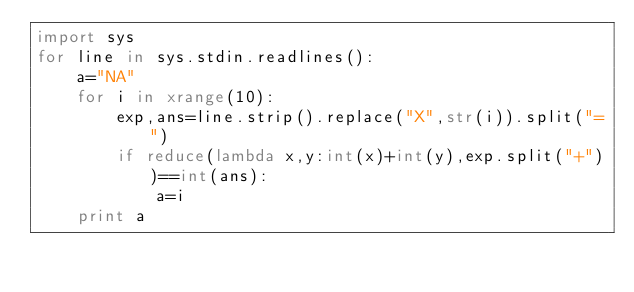Convert code to text. <code><loc_0><loc_0><loc_500><loc_500><_Python_>import sys
for line in sys.stdin.readlines():
    a="NA"
    for i in xrange(10):
        exp,ans=line.strip().replace("X",str(i)).split("=")
        if reduce(lambda x,y:int(x)+int(y),exp.split("+"))==int(ans):
            a=i
    print a</code> 